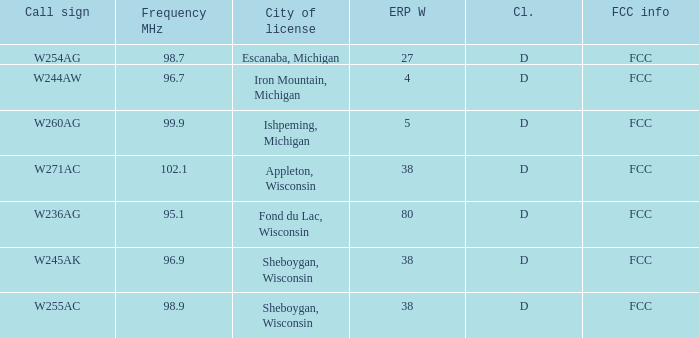What was the ERP W for 96.7 MHz? 4.0. 